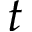Convert formula to latex. <formula><loc_0><loc_0><loc_500><loc_500>t</formula> 